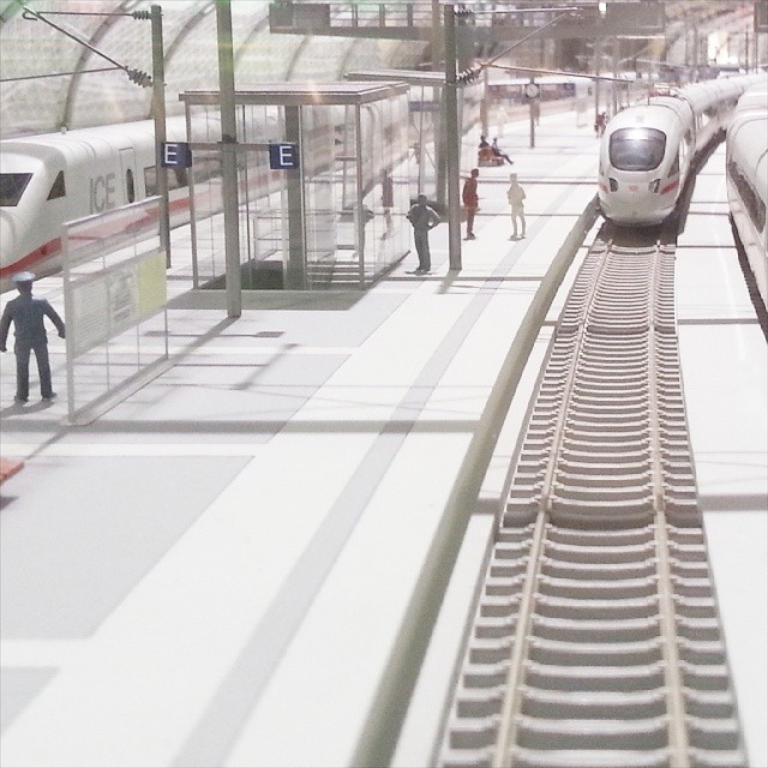Provide a one-sentence caption for the provided image. A train that is at a station and has ICE written on the side of it. 